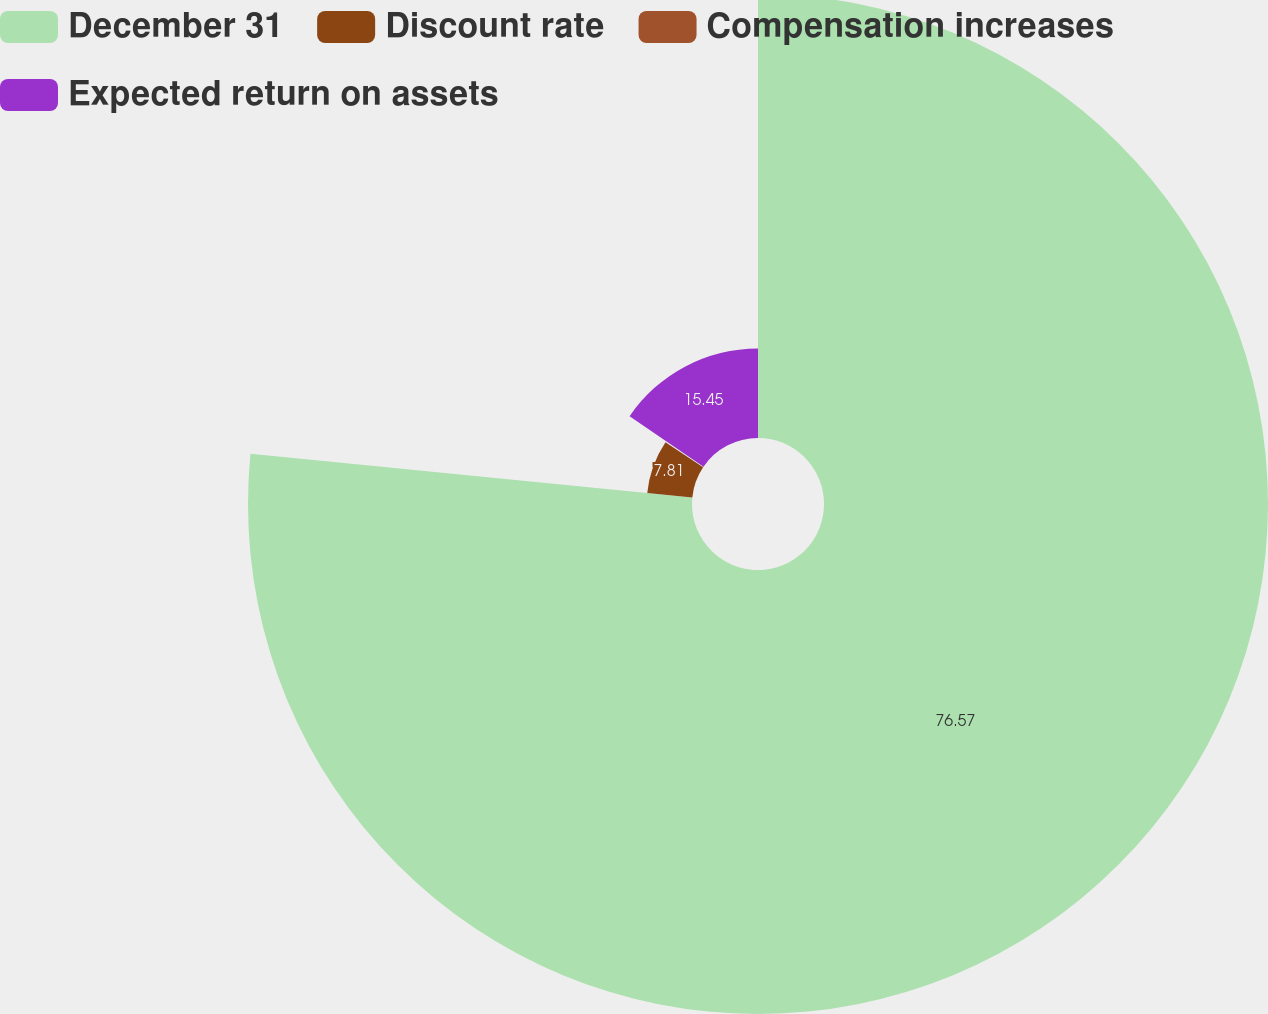<chart> <loc_0><loc_0><loc_500><loc_500><pie_chart><fcel>December 31<fcel>Discount rate<fcel>Compensation increases<fcel>Expected return on assets<nl><fcel>76.57%<fcel>7.81%<fcel>0.17%<fcel>15.45%<nl></chart> 